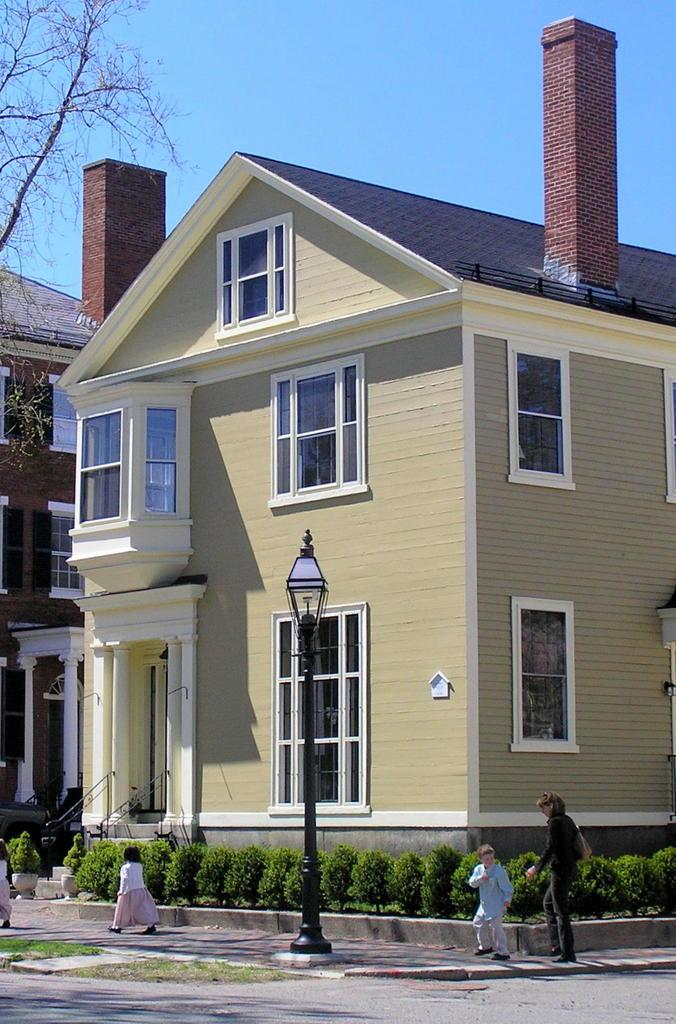What is the main object in the image? There is a pole in the image. What type of vegetation can be seen in the image? There are plants and grass in the image. What architectural features are present in the image? There are windows and buildings in the image. Can you describe the people in the image? There are people in the image. What is visible in the background of the image? The sky is visible in the background of the image. What other natural elements can be seen in the image? There are branches in the image. Where is the calendar located in the image? There is no calendar present in the image. What type of tub can be seen in the image? There is no tub present in the image. 